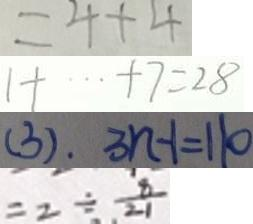Convert formula to latex. <formula><loc_0><loc_0><loc_500><loc_500>= 4 + 4 
 1 + \cdots + 7 = 2 8 
 ( 3 ) . 3 n - 1 = 1 1 0 
 = 2 \div \frac { 8 } { 2 1 }</formula> 